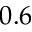Convert formula to latex. <formula><loc_0><loc_0><loc_500><loc_500>0 . 6</formula> 